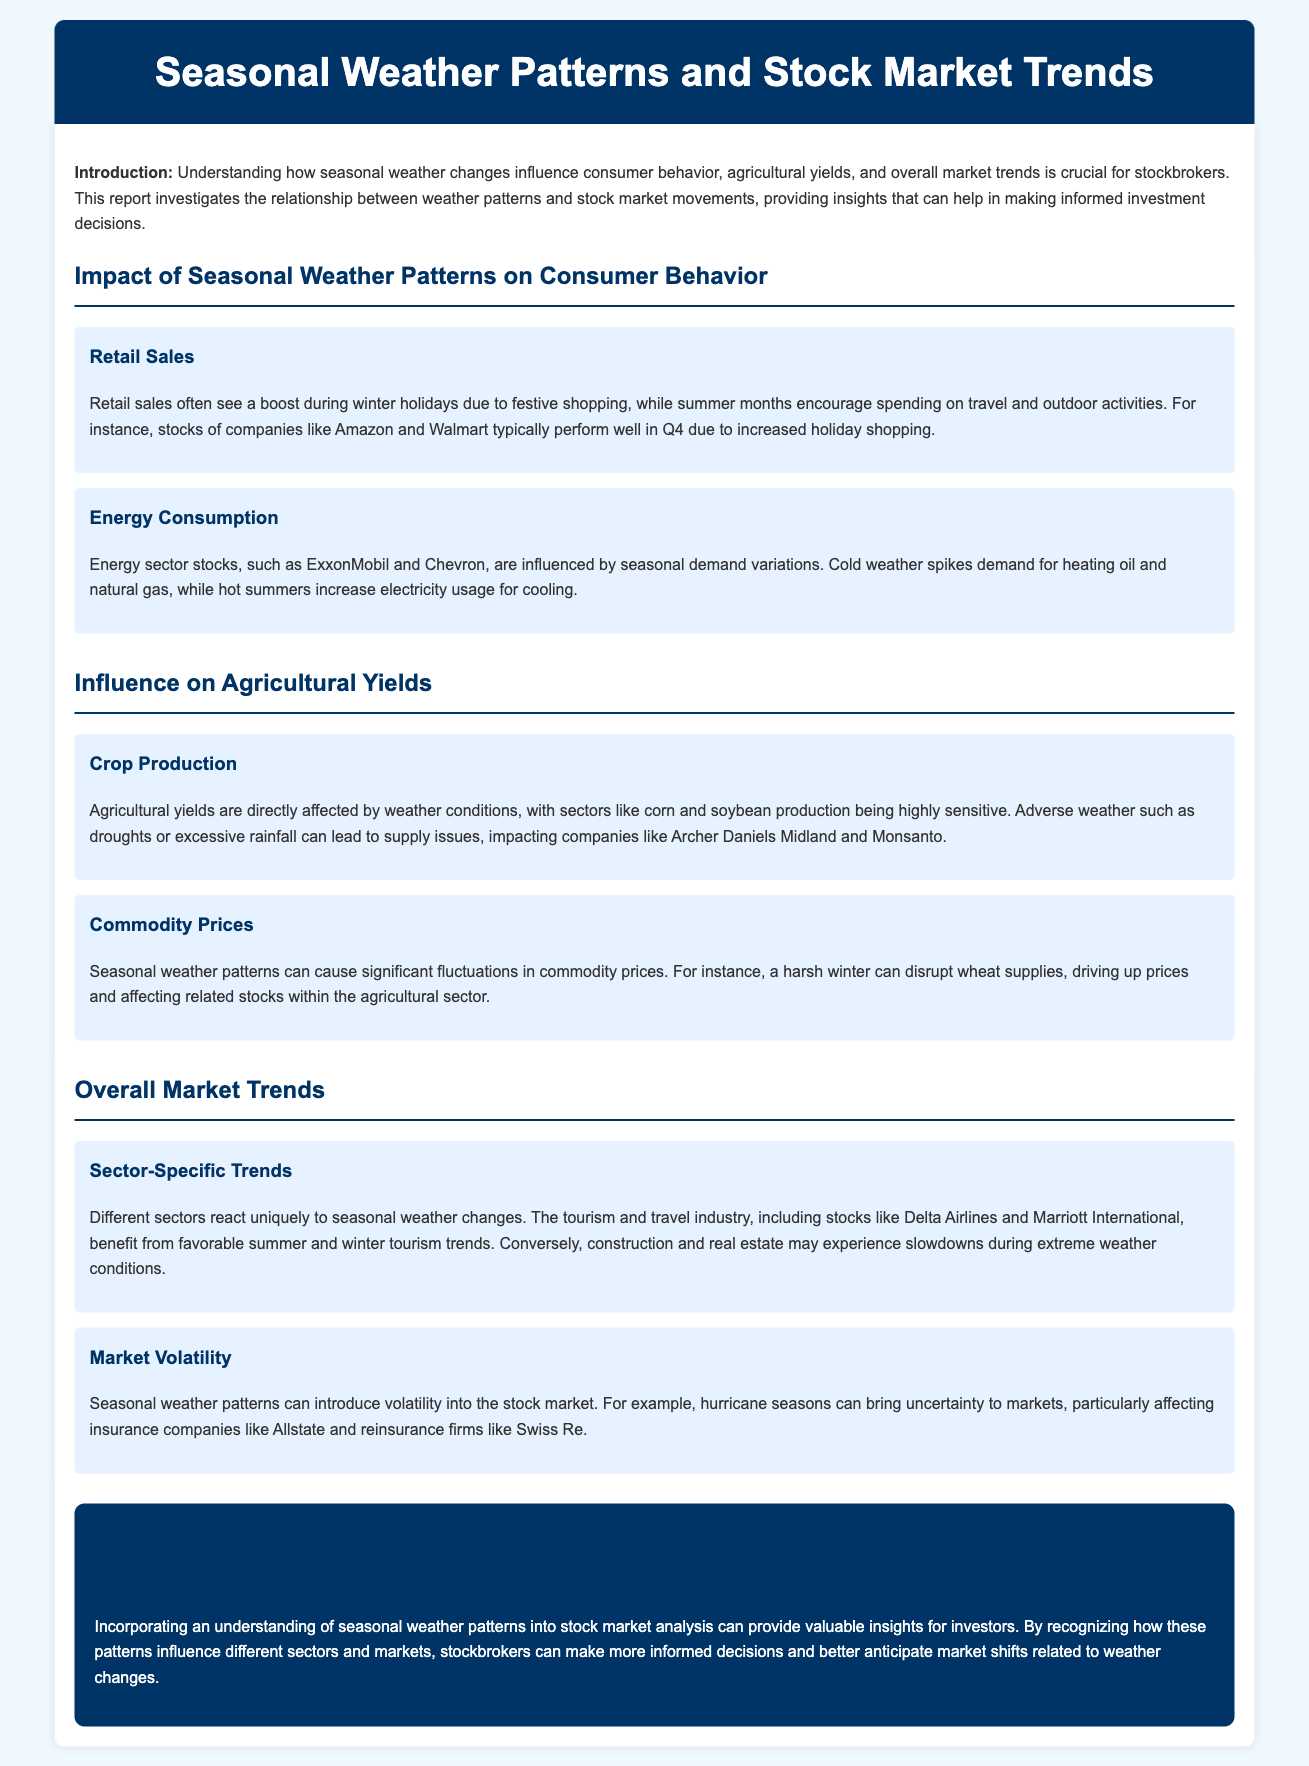What is the title of the report? The title of the report is provided in the header of the document.
Answer: Seasonal Weather Patterns and Stock Market Trends What is one major factor that influences retail sales during the winter? The paragraph discusses the impact of festive shopping on retail sales during the winter months.
Answer: Festive shopping Which two companies' stocks are mentioned in relation to energy consumption? The report identifies specific energy sector companies that are influenced by seasonal demand variations.
Answer: ExxonMobil and Chevron What crop production is highly sensitive to weather conditions? The document states that corn and soybean production are directly affected by weather conditions.
Answer: Corn and soybean What industry benefits from favorable summer and winter tourism trends? The section highlights the positive impact of seasonal weather on a specific industry.
Answer: Tourism and travel Which sectors experience slowdowns during extreme weather conditions? The document notes that certain sectors have specific responses to adverse weather, including a slowdown.
Answer: Construction and real estate What do seasonal weather patterns introduce to the stock market? The content refers to the effects of seasonal weather on market stability.
Answer: Volatility What conclusion can be drawn about stock market analysis? The conclusion summarizes the importance of integrating weather patterns into market analysis for better decision-making.
Answer: Valuable insights for investors Which two companies are affected by hurricane seasons? The report lists insurance firms significantly impacted by hurricane seasons.
Answer: Allstate and Swiss Re 